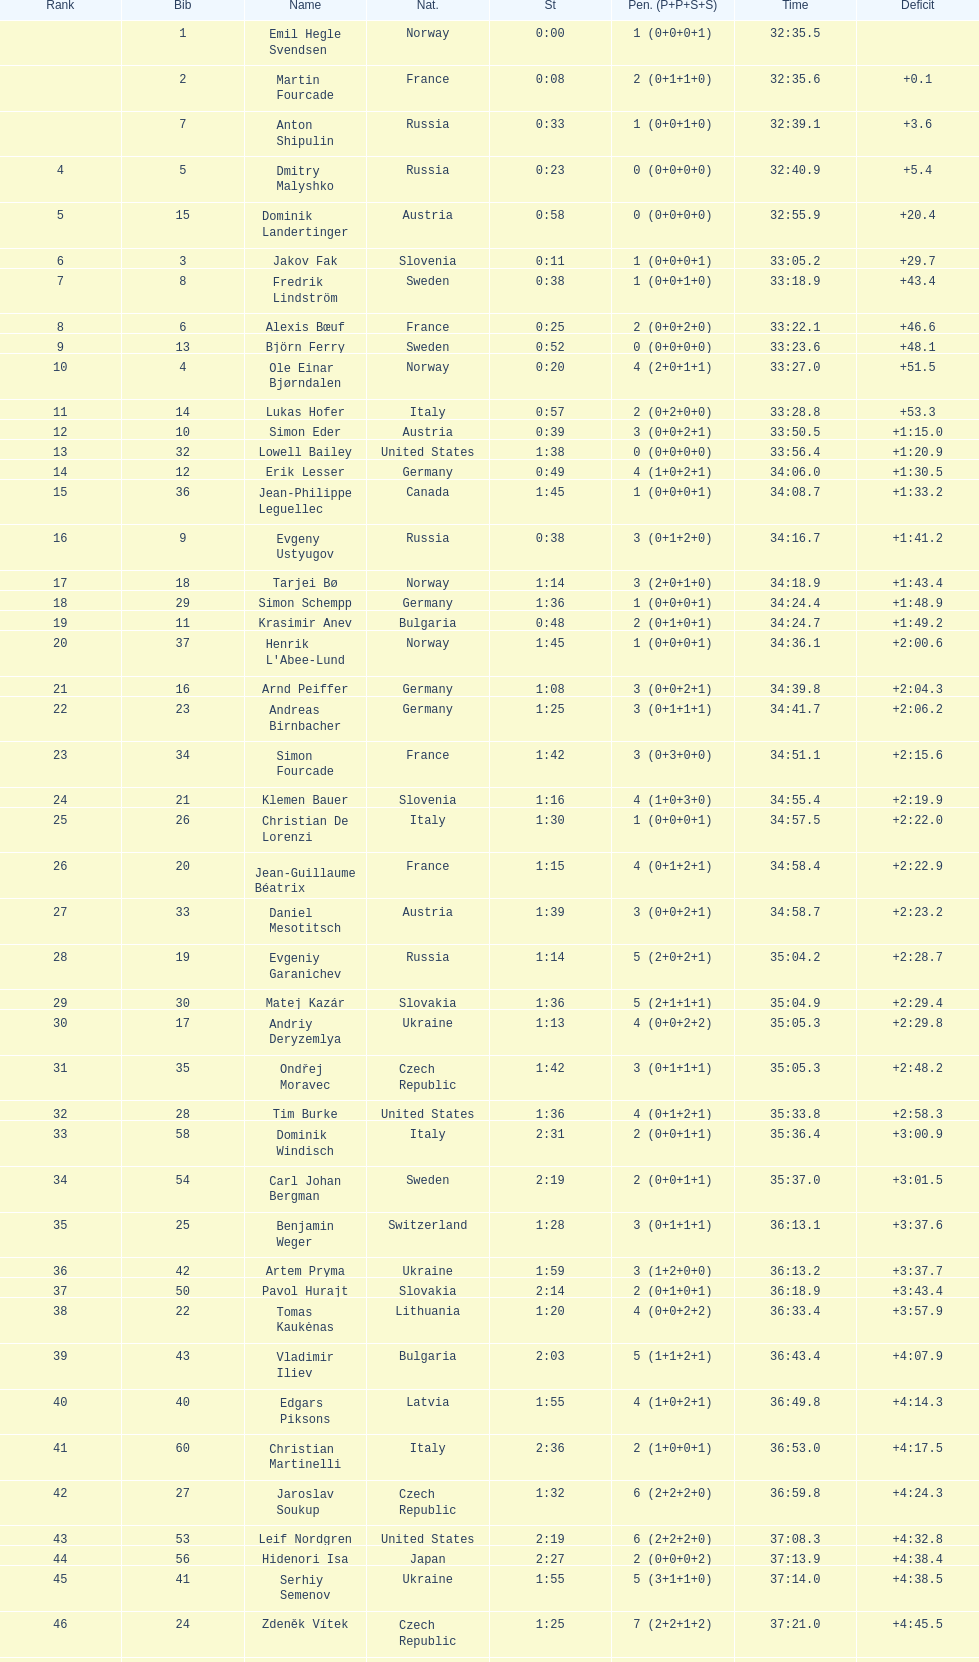What is the largest penalty? 10. 